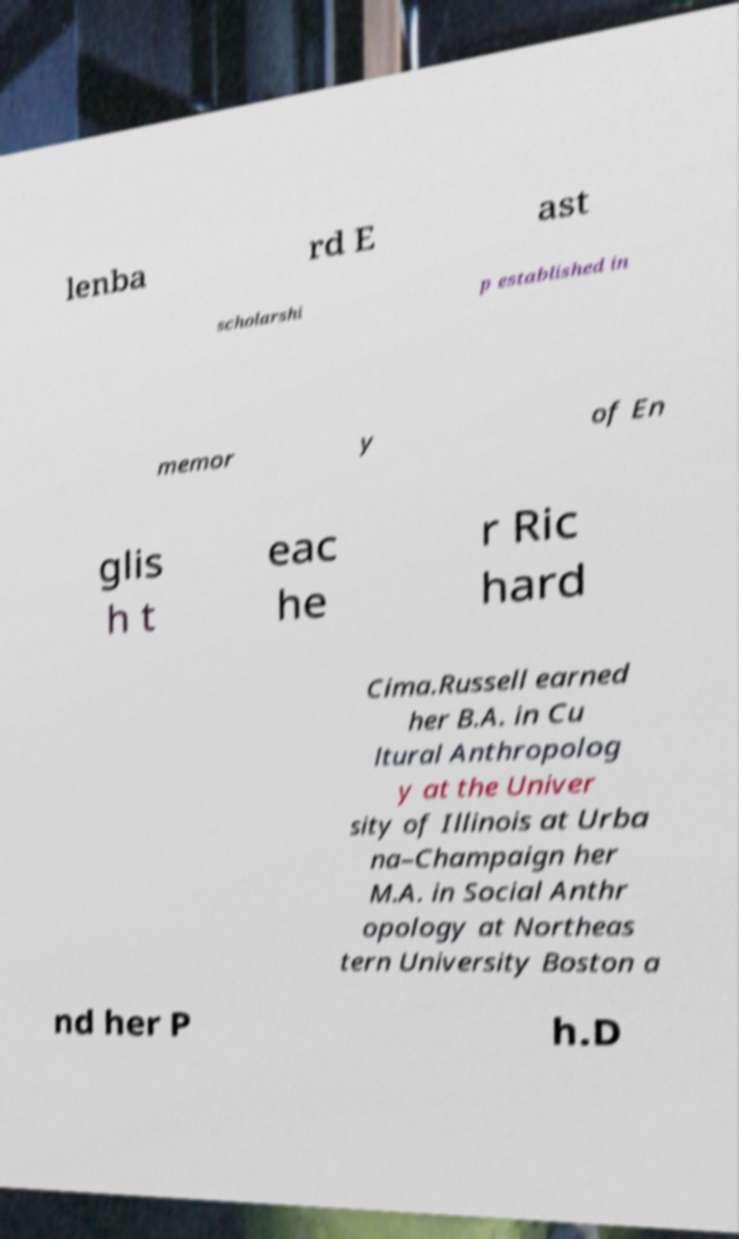Please read and relay the text visible in this image. What does it say? lenba rd E ast scholarshi p established in memor y of En glis h t eac he r Ric hard Cima.Russell earned her B.A. in Cu ltural Anthropolog y at the Univer sity of Illinois at Urba na–Champaign her M.A. in Social Anthr opology at Northeas tern University Boston a nd her P h.D 